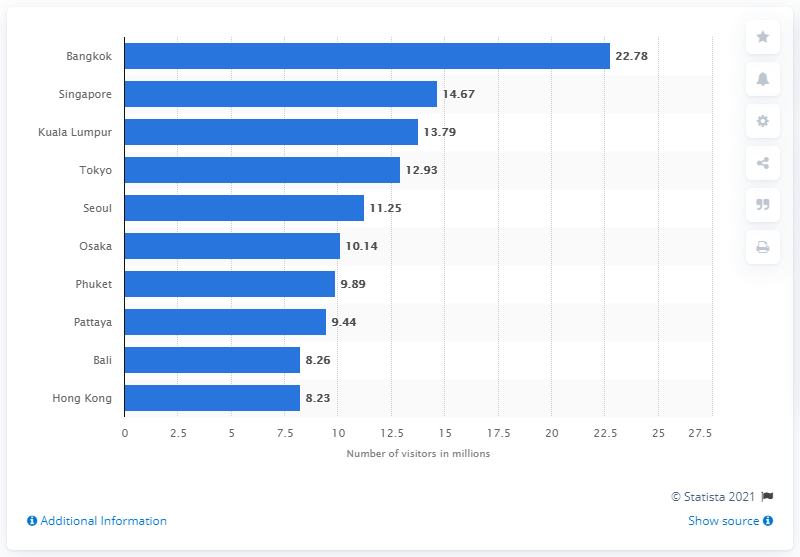Please compare the number of visitors in Bangkok to the other cities shown. Based on the image, Bangkok leads the list with 22.78 million visitors, followed by Singapore with 14.67 million, and Kuala Lumpur with 13.79 million. Tokyo, Seoul, and other cities follow with fewer visitors. 